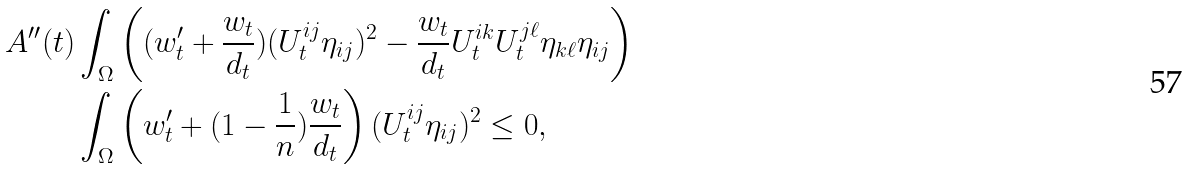Convert formula to latex. <formula><loc_0><loc_0><loc_500><loc_500>A ^ { \prime \prime } ( t ) & \int _ { \Omega } \left ( ( w _ { t } ^ { \prime } + \frac { w _ { t } } { d _ { t } } ) ( U _ { t } ^ { i j } \eta _ { i j } ) ^ { 2 } - \frac { w _ { t } } { d _ { t } } U _ { t } ^ { i k } U _ { t } ^ { j \ell } \eta _ { k \ell } \eta _ { i j } \right ) \\ & \int _ { \Omega } \left ( w _ { t } ^ { \prime } + ( 1 - \frac { 1 } { n } ) \frac { w _ { t } } { d _ { t } } \right ) ( U _ { t } ^ { i j } \eta _ { i j } ) ^ { 2 } \leq 0 ,</formula> 